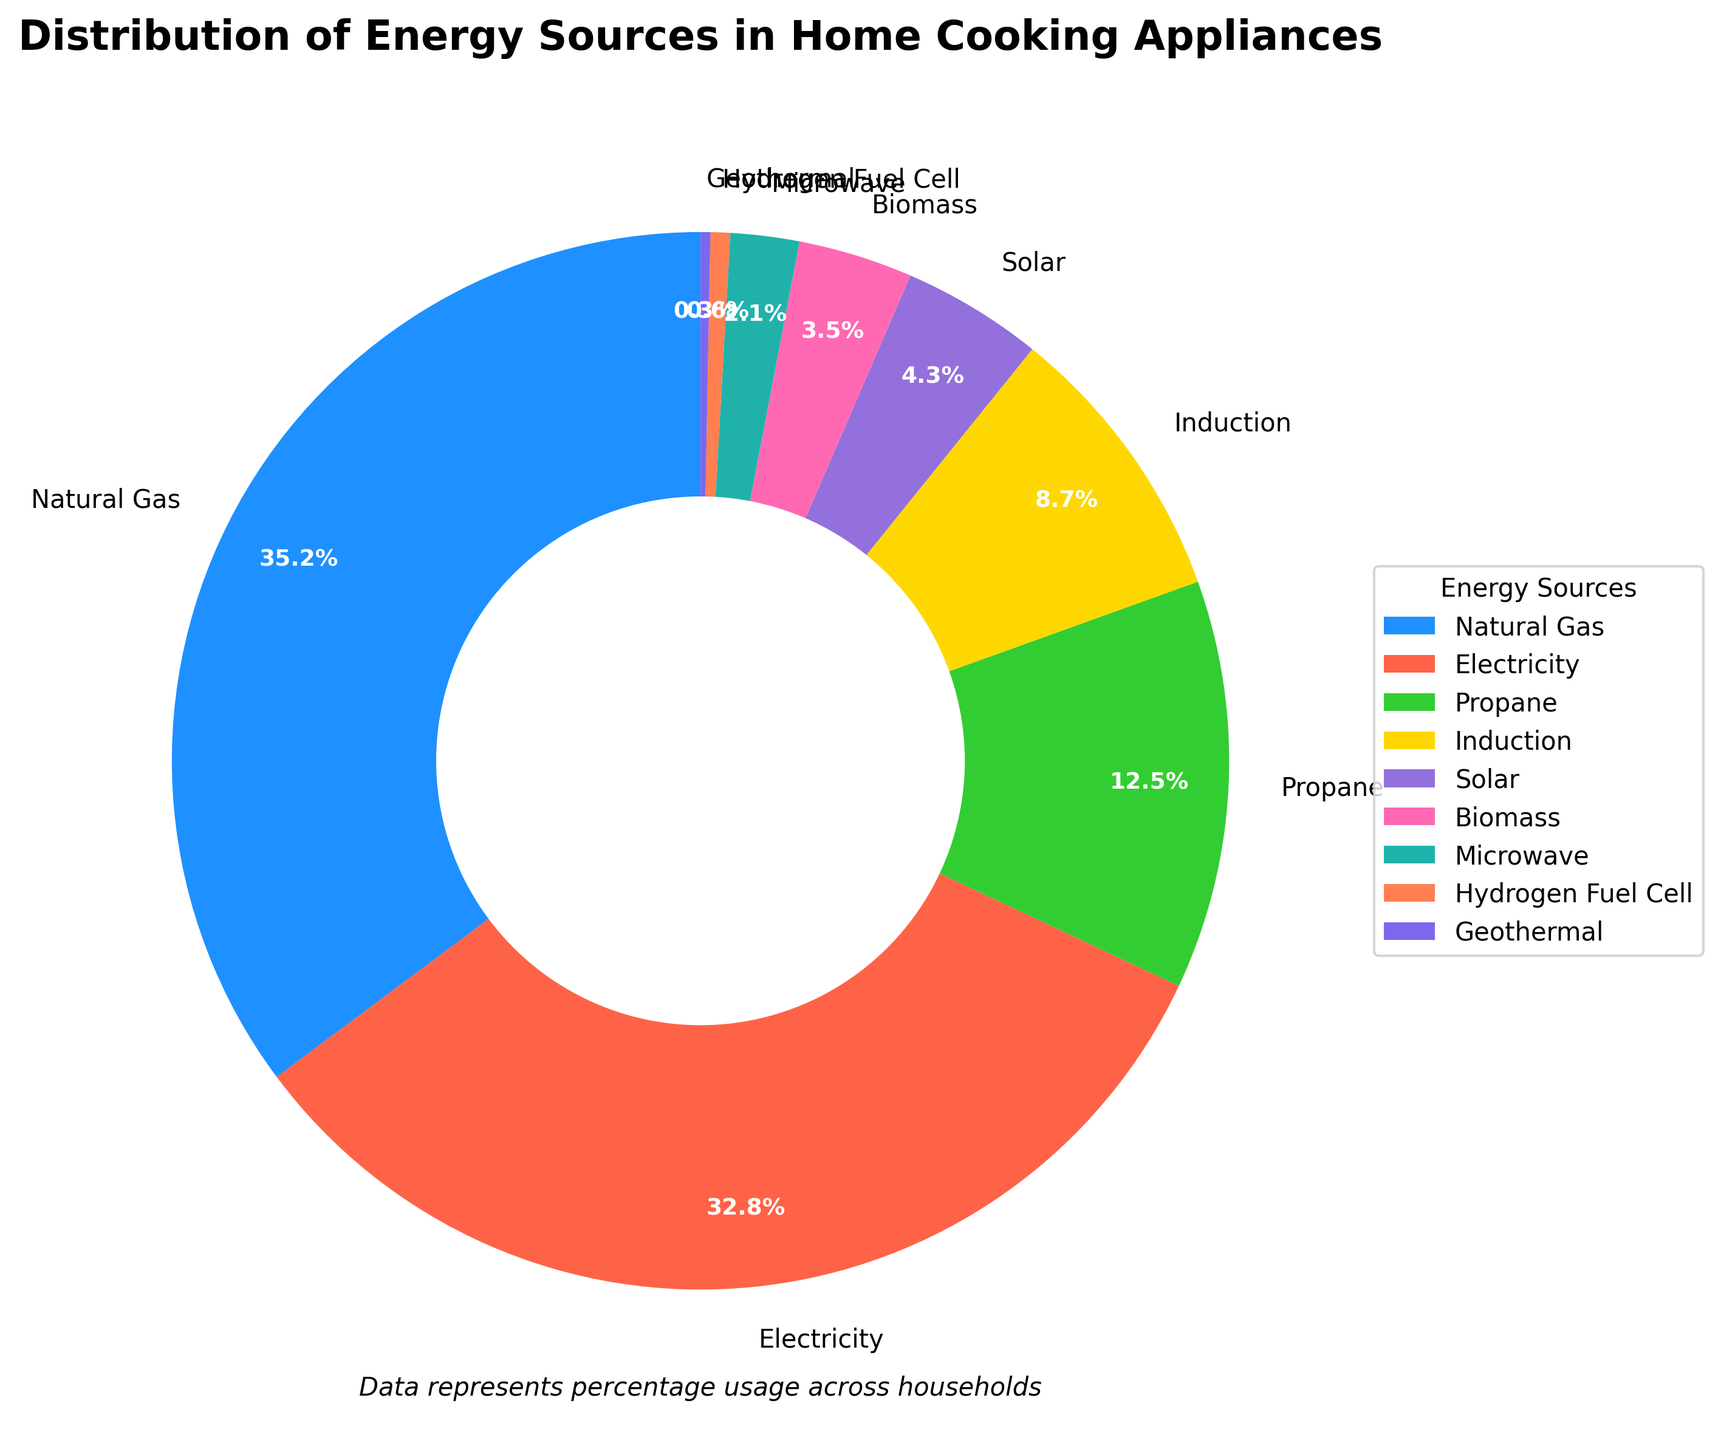Which energy source is used the most in home cooking appliances? Look at the pie chart and identify the largest segment which represents the highest percentage. Natural Gas makes up 35.2% of the total, which is the largest segment.
Answer: Natural Gas What percentage of households use induction cooktops? Refer to the pie chart and find the segment labeled "Induction". The chart shows that Induction is 8.7%.
Answer: 8.7% How much more common is Natural Gas compared to Solar energy in home cooking appliances? Compare the percentages of Natural Gas and Solar. Natural Gas is 35.2% while Solar is 4.3%. Subtract 4.3% from 35.2% to find the difference.
Answer: 30.9% Which energy sources combined have a smaller percentage than Induction? Identify the segments with a percentage smaller than 8.7%. Summing up Biomass (3.5%), Microwave (2.1%), Hydrogen Fuel Cell (0.6%), and Geothermal (0.3%) gives 6.5%, which is less than Induction's 8.7%.
Answer: Biomass, Microwave, Hydrogen Fuel Cell, Geothermal Are there more households using electricity or propane for cooking? Compare the segments for Electricity and Propane. Electricity makes up 32.8% while Propane is 12.5%.
Answer: Electricity What is the total percentage of households using renewable energy sources (Solar, Biomass, Geothermal)? Identify the renewable sources and sum their percentages. Solar (4.3%), Biomass (3.5%), and Geothermal (0.3%) add up to 8.1%.
Answer: 8.1% What proportion of households uses hydrogen fuel cells for cooking compared to the total for natural gas? Find the percentages of Hydrogen Fuel Cell and Natural Gas and express one as a fraction of the other. Hydrogen Fuel Cell is 0.6% and Natural Gas is 35.2%. Calculating 0.6 / 35.2 gives approximately 0.017 or 1.7%.
Answer: 1.7% Which energy source represents the smallest segment in the pie chart? Look for the smallest segment in the chart, which corresponds to the smallest percentage. Hydrogen Fuel Cell is 0.6%, the smallest percentage.
Answer: Hydrogen Fuel Cell How much more common is electricity compared to all renewable sources combined (Solar, Biomass, Geothermal)? First, sum the percentage of renewable sources (8.1%), then compare this to Electricity (32.8%). Subtract 8.1% from 32.8% to find the difference.
Answer: 24.7% Are natural gas and propane together more common than electricity? Add the percentages of Natural Gas and Propane, then compare this sum to Electricity. Natural Gas (35.2%) + Propane (12.5%) = 47.7%, which is more than Electricity's 32.8%.
Answer: Yes 